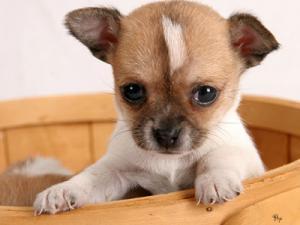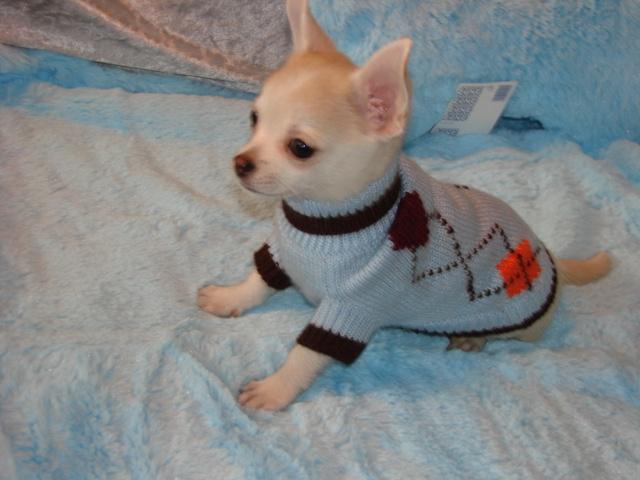The first image is the image on the left, the second image is the image on the right. Given the left and right images, does the statement "There is a single all white dog in the image on the right." hold true? Answer yes or no. No. The first image is the image on the left, the second image is the image on the right. Assess this claim about the two images: "A small dog is sitting next to a red object.". Correct or not? Answer yes or no. No. 